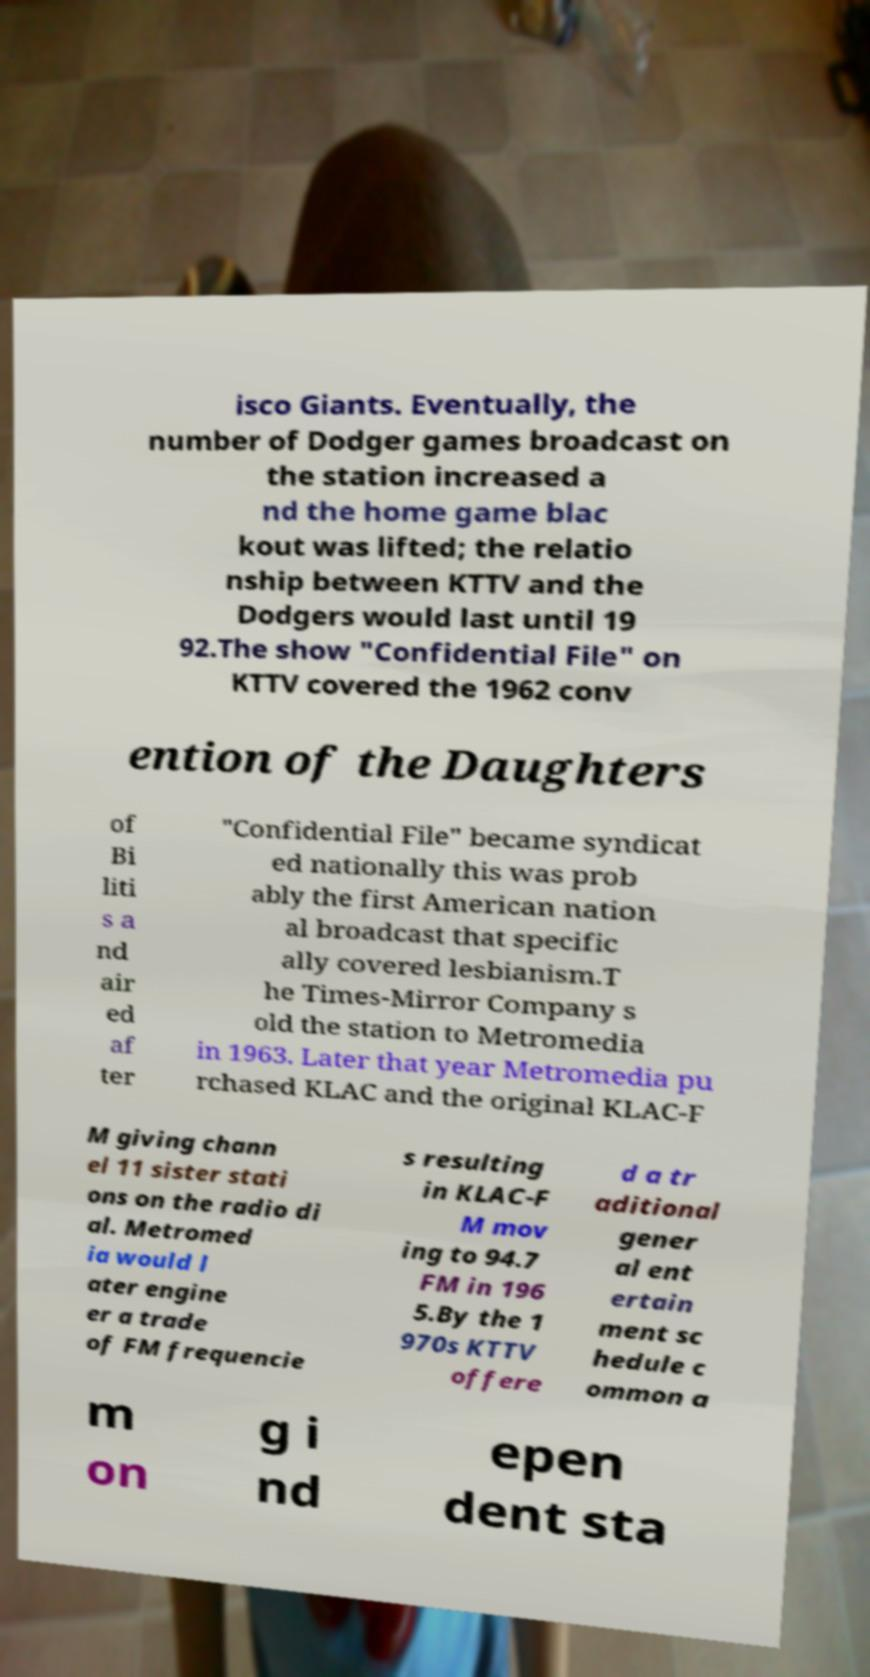Please read and relay the text visible in this image. What does it say? isco Giants. Eventually, the number of Dodger games broadcast on the station increased a nd the home game blac kout was lifted; the relatio nship between KTTV and the Dodgers would last until 19 92.The show "Confidential File" on KTTV covered the 1962 conv ention of the Daughters of Bi liti s a nd air ed af ter "Confidential File" became syndicat ed nationally this was prob ably the first American nation al broadcast that specific ally covered lesbianism.T he Times-Mirror Company s old the station to Metromedia in 1963. Later that year Metromedia pu rchased KLAC and the original KLAC-F M giving chann el 11 sister stati ons on the radio di al. Metromed ia would l ater engine er a trade of FM frequencie s resulting in KLAC-F M mov ing to 94.7 FM in 196 5.By the 1 970s KTTV offere d a tr aditional gener al ent ertain ment sc hedule c ommon a m on g i nd epen dent sta 